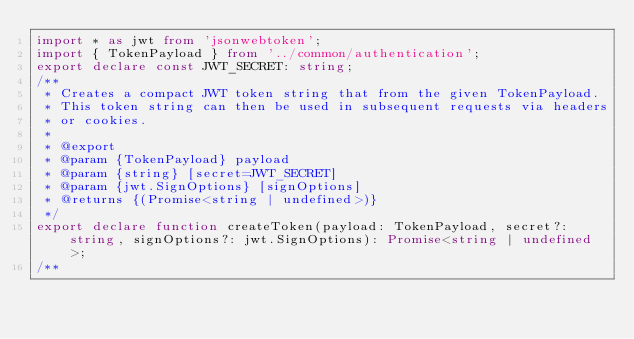Convert code to text. <code><loc_0><loc_0><loc_500><loc_500><_TypeScript_>import * as jwt from 'jsonwebtoken';
import { TokenPayload } from '../common/authentication';
export declare const JWT_SECRET: string;
/**
 * Creates a compact JWT token string that from the given TokenPayload.
 * This token string can then be used in subsequent requests via headers
 * or cookies.
 *
 * @export
 * @param {TokenPayload} payload
 * @param {string} [secret=JWT_SECRET]
 * @param {jwt.SignOptions} [signOptions]
 * @returns {(Promise<string | undefined>)}
 */
export declare function createToken(payload: TokenPayload, secret?: string, signOptions?: jwt.SignOptions): Promise<string | undefined>;
/**</code> 